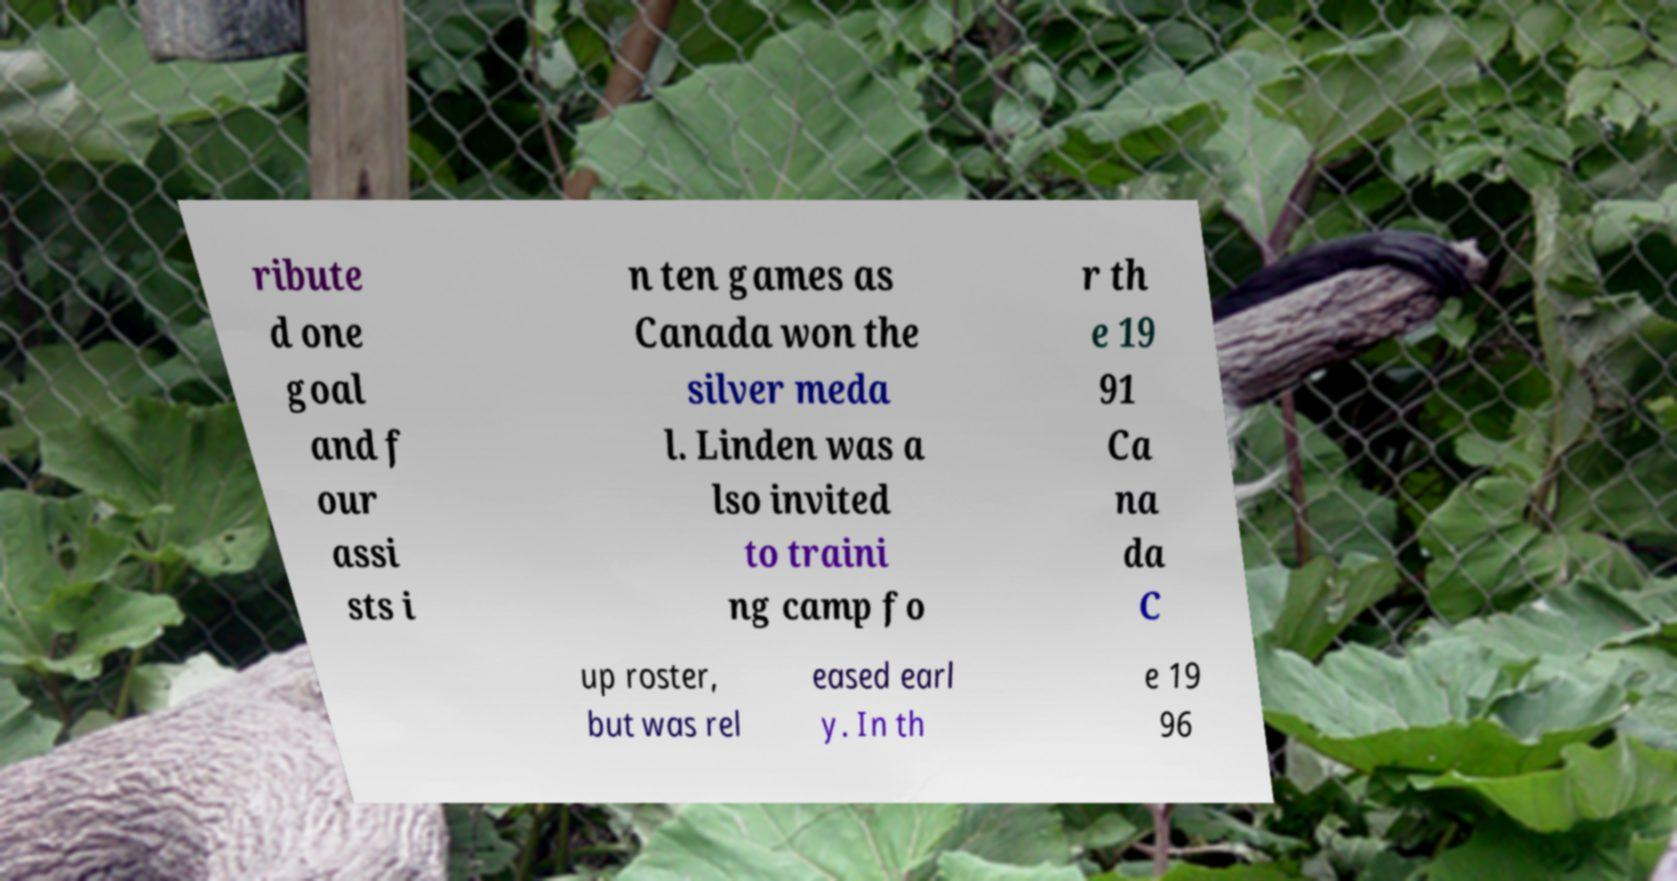Could you extract and type out the text from this image? ribute d one goal and f our assi sts i n ten games as Canada won the silver meda l. Linden was a lso invited to traini ng camp fo r th e 19 91 Ca na da C up roster, but was rel eased earl y. In th e 19 96 